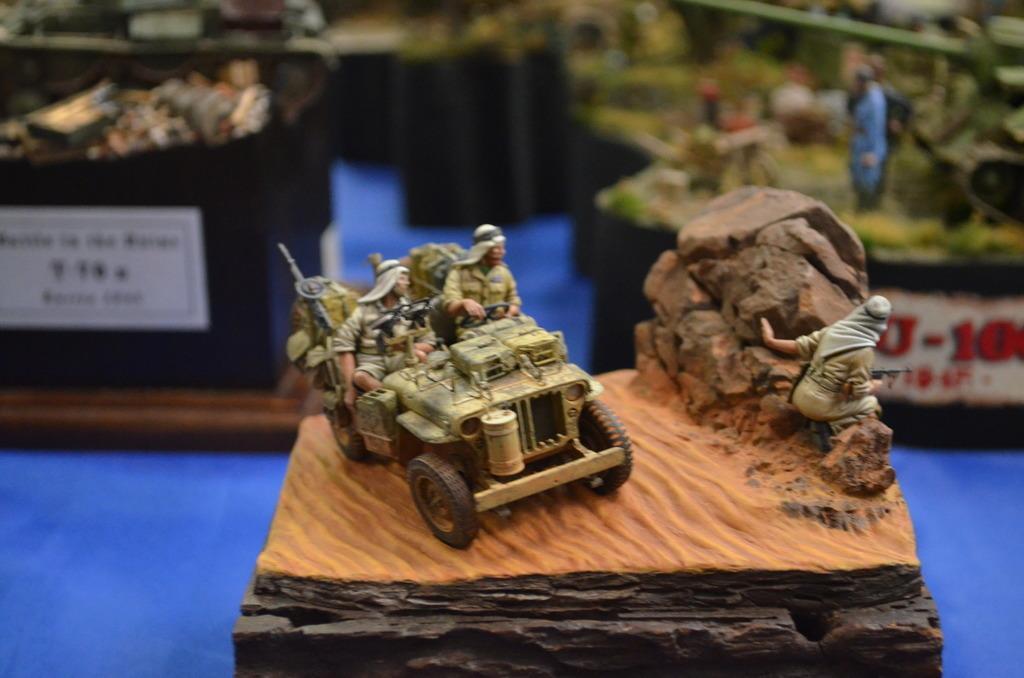Can you describe this image briefly? In this image we can see toys and stickers. Background it is blur. 